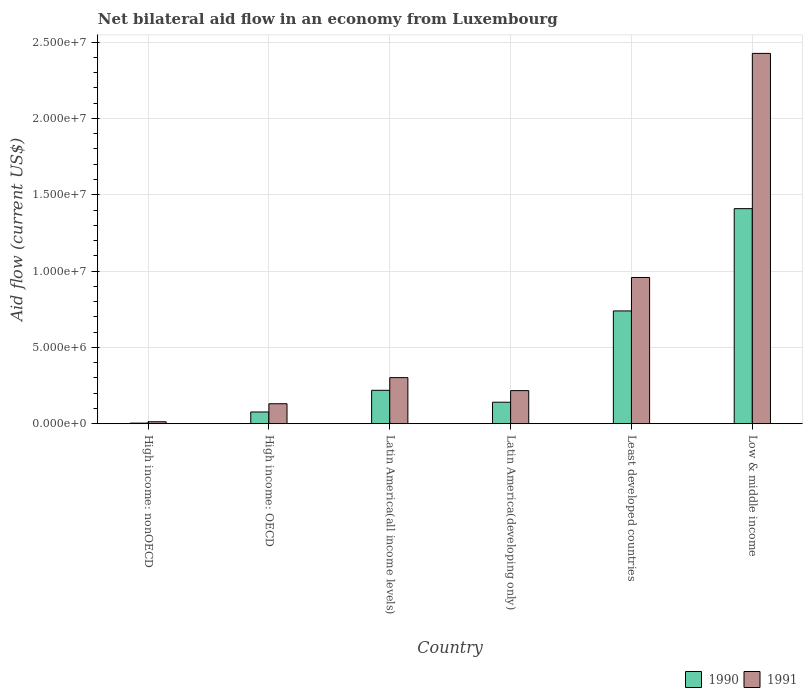How many groups of bars are there?
Keep it short and to the point. 6. Are the number of bars per tick equal to the number of legend labels?
Provide a succinct answer. Yes. Are the number of bars on each tick of the X-axis equal?
Provide a succinct answer. Yes. What is the label of the 5th group of bars from the left?
Make the answer very short. Least developed countries. In how many cases, is the number of bars for a given country not equal to the number of legend labels?
Ensure brevity in your answer.  0. What is the net bilateral aid flow in 1990 in Low & middle income?
Ensure brevity in your answer.  1.41e+07. Across all countries, what is the maximum net bilateral aid flow in 1991?
Offer a very short reply. 2.43e+07. In which country was the net bilateral aid flow in 1991 minimum?
Your answer should be very brief. High income: nonOECD. What is the total net bilateral aid flow in 1991 in the graph?
Your response must be concise. 4.05e+07. What is the difference between the net bilateral aid flow in 1991 in High income: OECD and that in Latin America(all income levels)?
Your answer should be very brief. -1.71e+06. What is the difference between the net bilateral aid flow in 1991 in Latin America(all income levels) and the net bilateral aid flow in 1990 in High income: OECD?
Keep it short and to the point. 2.25e+06. What is the average net bilateral aid flow in 1990 per country?
Give a very brief answer. 4.32e+06. What is the difference between the net bilateral aid flow of/in 1990 and net bilateral aid flow of/in 1991 in Least developed countries?
Provide a succinct answer. -2.19e+06. What is the ratio of the net bilateral aid flow in 1991 in High income: nonOECD to that in Least developed countries?
Give a very brief answer. 0.01. What is the difference between the highest and the second highest net bilateral aid flow in 1991?
Provide a succinct answer. 1.47e+07. What is the difference between the highest and the lowest net bilateral aid flow in 1990?
Ensure brevity in your answer.  1.40e+07. In how many countries, is the net bilateral aid flow in 1990 greater than the average net bilateral aid flow in 1990 taken over all countries?
Make the answer very short. 2. What does the 2nd bar from the left in Least developed countries represents?
Provide a succinct answer. 1991. What does the 1st bar from the right in High income: nonOECD represents?
Offer a terse response. 1991. Are all the bars in the graph horizontal?
Ensure brevity in your answer.  No. Does the graph contain any zero values?
Provide a succinct answer. No. Does the graph contain grids?
Give a very brief answer. Yes. What is the title of the graph?
Keep it short and to the point. Net bilateral aid flow in an economy from Luxembourg. What is the label or title of the X-axis?
Offer a terse response. Country. What is the label or title of the Y-axis?
Provide a succinct answer. Aid flow (current US$). What is the Aid flow (current US$) of 1991 in High income: nonOECD?
Your answer should be compact. 1.30e+05. What is the Aid flow (current US$) in 1990 in High income: OECD?
Offer a very short reply. 7.70e+05. What is the Aid flow (current US$) in 1991 in High income: OECD?
Make the answer very short. 1.31e+06. What is the Aid flow (current US$) in 1990 in Latin America(all income levels)?
Provide a succinct answer. 2.19e+06. What is the Aid flow (current US$) of 1991 in Latin America(all income levels)?
Give a very brief answer. 3.02e+06. What is the Aid flow (current US$) in 1990 in Latin America(developing only)?
Keep it short and to the point. 1.41e+06. What is the Aid flow (current US$) in 1991 in Latin America(developing only)?
Give a very brief answer. 2.17e+06. What is the Aid flow (current US$) in 1990 in Least developed countries?
Your answer should be very brief. 7.39e+06. What is the Aid flow (current US$) of 1991 in Least developed countries?
Keep it short and to the point. 9.58e+06. What is the Aid flow (current US$) in 1990 in Low & middle income?
Provide a succinct answer. 1.41e+07. What is the Aid flow (current US$) of 1991 in Low & middle income?
Your answer should be very brief. 2.43e+07. Across all countries, what is the maximum Aid flow (current US$) of 1990?
Your answer should be very brief. 1.41e+07. Across all countries, what is the maximum Aid flow (current US$) in 1991?
Your answer should be very brief. 2.43e+07. Across all countries, what is the minimum Aid flow (current US$) of 1991?
Your answer should be very brief. 1.30e+05. What is the total Aid flow (current US$) in 1990 in the graph?
Offer a terse response. 2.59e+07. What is the total Aid flow (current US$) in 1991 in the graph?
Ensure brevity in your answer.  4.05e+07. What is the difference between the Aid flow (current US$) of 1990 in High income: nonOECD and that in High income: OECD?
Keep it short and to the point. -7.30e+05. What is the difference between the Aid flow (current US$) of 1991 in High income: nonOECD and that in High income: OECD?
Your answer should be very brief. -1.18e+06. What is the difference between the Aid flow (current US$) in 1990 in High income: nonOECD and that in Latin America(all income levels)?
Your response must be concise. -2.15e+06. What is the difference between the Aid flow (current US$) of 1991 in High income: nonOECD and that in Latin America(all income levels)?
Your response must be concise. -2.89e+06. What is the difference between the Aid flow (current US$) in 1990 in High income: nonOECD and that in Latin America(developing only)?
Provide a short and direct response. -1.37e+06. What is the difference between the Aid flow (current US$) of 1991 in High income: nonOECD and that in Latin America(developing only)?
Ensure brevity in your answer.  -2.04e+06. What is the difference between the Aid flow (current US$) of 1990 in High income: nonOECD and that in Least developed countries?
Offer a very short reply. -7.35e+06. What is the difference between the Aid flow (current US$) of 1991 in High income: nonOECD and that in Least developed countries?
Your answer should be compact. -9.45e+06. What is the difference between the Aid flow (current US$) of 1990 in High income: nonOECD and that in Low & middle income?
Offer a terse response. -1.40e+07. What is the difference between the Aid flow (current US$) of 1991 in High income: nonOECD and that in Low & middle income?
Give a very brief answer. -2.41e+07. What is the difference between the Aid flow (current US$) of 1990 in High income: OECD and that in Latin America(all income levels)?
Offer a very short reply. -1.42e+06. What is the difference between the Aid flow (current US$) in 1991 in High income: OECD and that in Latin America(all income levels)?
Make the answer very short. -1.71e+06. What is the difference between the Aid flow (current US$) in 1990 in High income: OECD and that in Latin America(developing only)?
Ensure brevity in your answer.  -6.40e+05. What is the difference between the Aid flow (current US$) in 1991 in High income: OECD and that in Latin America(developing only)?
Ensure brevity in your answer.  -8.60e+05. What is the difference between the Aid flow (current US$) in 1990 in High income: OECD and that in Least developed countries?
Your response must be concise. -6.62e+06. What is the difference between the Aid flow (current US$) of 1991 in High income: OECD and that in Least developed countries?
Offer a very short reply. -8.27e+06. What is the difference between the Aid flow (current US$) of 1990 in High income: OECD and that in Low & middle income?
Keep it short and to the point. -1.33e+07. What is the difference between the Aid flow (current US$) of 1991 in High income: OECD and that in Low & middle income?
Your answer should be compact. -2.30e+07. What is the difference between the Aid flow (current US$) in 1990 in Latin America(all income levels) and that in Latin America(developing only)?
Provide a short and direct response. 7.80e+05. What is the difference between the Aid flow (current US$) of 1991 in Latin America(all income levels) and that in Latin America(developing only)?
Offer a terse response. 8.50e+05. What is the difference between the Aid flow (current US$) of 1990 in Latin America(all income levels) and that in Least developed countries?
Ensure brevity in your answer.  -5.20e+06. What is the difference between the Aid flow (current US$) in 1991 in Latin America(all income levels) and that in Least developed countries?
Your answer should be very brief. -6.56e+06. What is the difference between the Aid flow (current US$) of 1990 in Latin America(all income levels) and that in Low & middle income?
Give a very brief answer. -1.19e+07. What is the difference between the Aid flow (current US$) of 1991 in Latin America(all income levels) and that in Low & middle income?
Your answer should be very brief. -2.12e+07. What is the difference between the Aid flow (current US$) of 1990 in Latin America(developing only) and that in Least developed countries?
Offer a very short reply. -5.98e+06. What is the difference between the Aid flow (current US$) in 1991 in Latin America(developing only) and that in Least developed countries?
Make the answer very short. -7.41e+06. What is the difference between the Aid flow (current US$) of 1990 in Latin America(developing only) and that in Low & middle income?
Your response must be concise. -1.27e+07. What is the difference between the Aid flow (current US$) of 1991 in Latin America(developing only) and that in Low & middle income?
Provide a short and direct response. -2.21e+07. What is the difference between the Aid flow (current US$) in 1990 in Least developed countries and that in Low & middle income?
Give a very brief answer. -6.70e+06. What is the difference between the Aid flow (current US$) of 1991 in Least developed countries and that in Low & middle income?
Your answer should be very brief. -1.47e+07. What is the difference between the Aid flow (current US$) in 1990 in High income: nonOECD and the Aid flow (current US$) in 1991 in High income: OECD?
Offer a terse response. -1.27e+06. What is the difference between the Aid flow (current US$) in 1990 in High income: nonOECD and the Aid flow (current US$) in 1991 in Latin America(all income levels)?
Provide a short and direct response. -2.98e+06. What is the difference between the Aid flow (current US$) of 1990 in High income: nonOECD and the Aid flow (current US$) of 1991 in Latin America(developing only)?
Provide a succinct answer. -2.13e+06. What is the difference between the Aid flow (current US$) in 1990 in High income: nonOECD and the Aid flow (current US$) in 1991 in Least developed countries?
Give a very brief answer. -9.54e+06. What is the difference between the Aid flow (current US$) in 1990 in High income: nonOECD and the Aid flow (current US$) in 1991 in Low & middle income?
Provide a succinct answer. -2.42e+07. What is the difference between the Aid flow (current US$) of 1990 in High income: OECD and the Aid flow (current US$) of 1991 in Latin America(all income levels)?
Offer a terse response. -2.25e+06. What is the difference between the Aid flow (current US$) in 1990 in High income: OECD and the Aid flow (current US$) in 1991 in Latin America(developing only)?
Give a very brief answer. -1.40e+06. What is the difference between the Aid flow (current US$) of 1990 in High income: OECD and the Aid flow (current US$) of 1991 in Least developed countries?
Keep it short and to the point. -8.81e+06. What is the difference between the Aid flow (current US$) of 1990 in High income: OECD and the Aid flow (current US$) of 1991 in Low & middle income?
Provide a succinct answer. -2.35e+07. What is the difference between the Aid flow (current US$) in 1990 in Latin America(all income levels) and the Aid flow (current US$) in 1991 in Least developed countries?
Your response must be concise. -7.39e+06. What is the difference between the Aid flow (current US$) of 1990 in Latin America(all income levels) and the Aid flow (current US$) of 1991 in Low & middle income?
Make the answer very short. -2.21e+07. What is the difference between the Aid flow (current US$) in 1990 in Latin America(developing only) and the Aid flow (current US$) in 1991 in Least developed countries?
Your answer should be compact. -8.17e+06. What is the difference between the Aid flow (current US$) in 1990 in Latin America(developing only) and the Aid flow (current US$) in 1991 in Low & middle income?
Keep it short and to the point. -2.28e+07. What is the difference between the Aid flow (current US$) of 1990 in Least developed countries and the Aid flow (current US$) of 1991 in Low & middle income?
Your answer should be compact. -1.69e+07. What is the average Aid flow (current US$) in 1990 per country?
Give a very brief answer. 4.32e+06. What is the average Aid flow (current US$) in 1991 per country?
Provide a short and direct response. 6.74e+06. What is the difference between the Aid flow (current US$) of 1990 and Aid flow (current US$) of 1991 in High income: nonOECD?
Your response must be concise. -9.00e+04. What is the difference between the Aid flow (current US$) in 1990 and Aid flow (current US$) in 1991 in High income: OECD?
Ensure brevity in your answer.  -5.40e+05. What is the difference between the Aid flow (current US$) in 1990 and Aid flow (current US$) in 1991 in Latin America(all income levels)?
Provide a succinct answer. -8.30e+05. What is the difference between the Aid flow (current US$) of 1990 and Aid flow (current US$) of 1991 in Latin America(developing only)?
Provide a succinct answer. -7.60e+05. What is the difference between the Aid flow (current US$) in 1990 and Aid flow (current US$) in 1991 in Least developed countries?
Provide a short and direct response. -2.19e+06. What is the difference between the Aid flow (current US$) in 1990 and Aid flow (current US$) in 1991 in Low & middle income?
Make the answer very short. -1.02e+07. What is the ratio of the Aid flow (current US$) of 1990 in High income: nonOECD to that in High income: OECD?
Your answer should be very brief. 0.05. What is the ratio of the Aid flow (current US$) of 1991 in High income: nonOECD to that in High income: OECD?
Offer a terse response. 0.1. What is the ratio of the Aid flow (current US$) in 1990 in High income: nonOECD to that in Latin America(all income levels)?
Your answer should be very brief. 0.02. What is the ratio of the Aid flow (current US$) of 1991 in High income: nonOECD to that in Latin America(all income levels)?
Provide a succinct answer. 0.04. What is the ratio of the Aid flow (current US$) of 1990 in High income: nonOECD to that in Latin America(developing only)?
Provide a succinct answer. 0.03. What is the ratio of the Aid flow (current US$) of 1991 in High income: nonOECD to that in Latin America(developing only)?
Your answer should be very brief. 0.06. What is the ratio of the Aid flow (current US$) of 1990 in High income: nonOECD to that in Least developed countries?
Ensure brevity in your answer.  0.01. What is the ratio of the Aid flow (current US$) in 1991 in High income: nonOECD to that in Least developed countries?
Offer a terse response. 0.01. What is the ratio of the Aid flow (current US$) of 1990 in High income: nonOECD to that in Low & middle income?
Keep it short and to the point. 0. What is the ratio of the Aid flow (current US$) in 1991 in High income: nonOECD to that in Low & middle income?
Offer a very short reply. 0.01. What is the ratio of the Aid flow (current US$) in 1990 in High income: OECD to that in Latin America(all income levels)?
Provide a short and direct response. 0.35. What is the ratio of the Aid flow (current US$) in 1991 in High income: OECD to that in Latin America(all income levels)?
Your answer should be very brief. 0.43. What is the ratio of the Aid flow (current US$) of 1990 in High income: OECD to that in Latin America(developing only)?
Give a very brief answer. 0.55. What is the ratio of the Aid flow (current US$) of 1991 in High income: OECD to that in Latin America(developing only)?
Give a very brief answer. 0.6. What is the ratio of the Aid flow (current US$) of 1990 in High income: OECD to that in Least developed countries?
Provide a succinct answer. 0.1. What is the ratio of the Aid flow (current US$) of 1991 in High income: OECD to that in Least developed countries?
Offer a terse response. 0.14. What is the ratio of the Aid flow (current US$) of 1990 in High income: OECD to that in Low & middle income?
Ensure brevity in your answer.  0.05. What is the ratio of the Aid flow (current US$) of 1991 in High income: OECD to that in Low & middle income?
Provide a succinct answer. 0.05. What is the ratio of the Aid flow (current US$) of 1990 in Latin America(all income levels) to that in Latin America(developing only)?
Provide a short and direct response. 1.55. What is the ratio of the Aid flow (current US$) in 1991 in Latin America(all income levels) to that in Latin America(developing only)?
Ensure brevity in your answer.  1.39. What is the ratio of the Aid flow (current US$) of 1990 in Latin America(all income levels) to that in Least developed countries?
Keep it short and to the point. 0.3. What is the ratio of the Aid flow (current US$) of 1991 in Latin America(all income levels) to that in Least developed countries?
Offer a very short reply. 0.32. What is the ratio of the Aid flow (current US$) of 1990 in Latin America(all income levels) to that in Low & middle income?
Make the answer very short. 0.16. What is the ratio of the Aid flow (current US$) of 1991 in Latin America(all income levels) to that in Low & middle income?
Provide a succinct answer. 0.12. What is the ratio of the Aid flow (current US$) in 1990 in Latin America(developing only) to that in Least developed countries?
Offer a terse response. 0.19. What is the ratio of the Aid flow (current US$) of 1991 in Latin America(developing only) to that in Least developed countries?
Give a very brief answer. 0.23. What is the ratio of the Aid flow (current US$) of 1990 in Latin America(developing only) to that in Low & middle income?
Offer a terse response. 0.1. What is the ratio of the Aid flow (current US$) in 1991 in Latin America(developing only) to that in Low & middle income?
Offer a terse response. 0.09. What is the ratio of the Aid flow (current US$) of 1990 in Least developed countries to that in Low & middle income?
Ensure brevity in your answer.  0.52. What is the ratio of the Aid flow (current US$) of 1991 in Least developed countries to that in Low & middle income?
Provide a short and direct response. 0.39. What is the difference between the highest and the second highest Aid flow (current US$) in 1990?
Provide a succinct answer. 6.70e+06. What is the difference between the highest and the second highest Aid flow (current US$) in 1991?
Offer a very short reply. 1.47e+07. What is the difference between the highest and the lowest Aid flow (current US$) in 1990?
Offer a very short reply. 1.40e+07. What is the difference between the highest and the lowest Aid flow (current US$) in 1991?
Keep it short and to the point. 2.41e+07. 